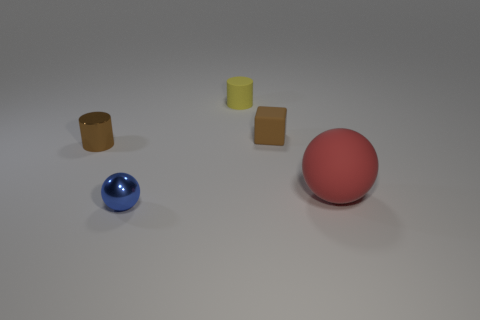Add 2 small yellow metallic balls. How many objects exist? 7 Subtract all cubes. How many objects are left? 4 Add 5 small brown matte blocks. How many small brown matte blocks are left? 6 Add 4 large yellow spheres. How many large yellow spheres exist? 4 Subtract 0 cyan cubes. How many objects are left? 5 Subtract all cylinders. Subtract all tiny cyan metal cylinders. How many objects are left? 3 